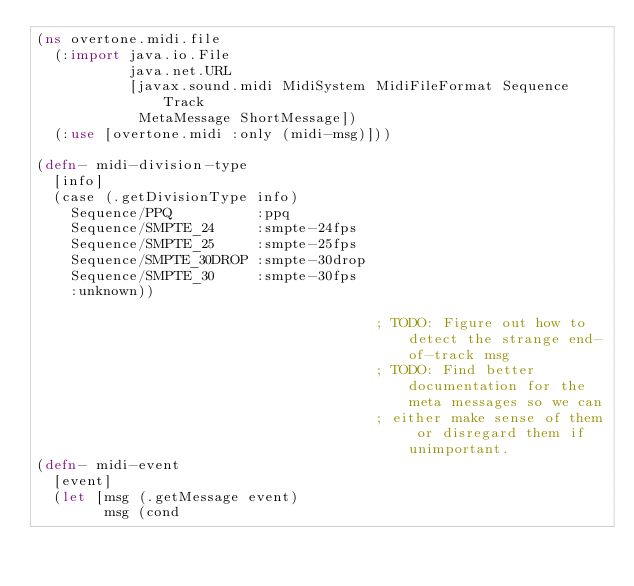<code> <loc_0><loc_0><loc_500><loc_500><_Clojure_>(ns overtone.midi.file
  (:import java.io.File
           java.net.URL
           [javax.sound.midi MidiSystem MidiFileFormat Sequence Track
            MetaMessage ShortMessage])
  (:use [overtone.midi :only (midi-msg)]))

(defn- midi-division-type
  [info]
  (case (.getDivisionType info)
    Sequence/PPQ          :ppq
    Sequence/SMPTE_24     :smpte-24fps
    Sequence/SMPTE_25     :smpte-25fps
    Sequence/SMPTE_30DROP :smpte-30drop
    Sequence/SMPTE_30     :smpte-30fps
    :unknown))

                                        ; TODO: Figure out how to detect the strange end-of-track msg
                                        ; TODO: Find better documentation for the meta messages so we can
                                        ; either make sense of them or disregard them if unimportant.
(defn- midi-event
  [event]
  (let [msg (.getMessage event)
        msg (cond</code> 